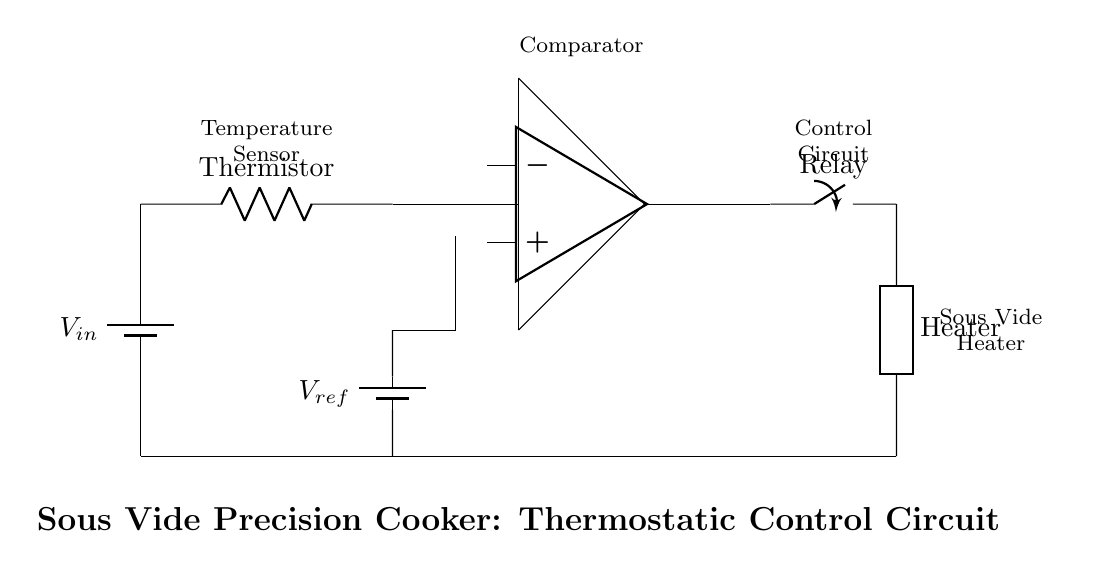What is the type of temperature sensor used? The circuit diagram indicates a thermistor is used as the temperature sensor, which is represented by the labeled resistor.
Answer: Thermistor What does the comparator do in this circuit? The comparator compares the voltage from the thermistor with the reference voltage to control the relay, allowing the heater to turn on or off based on the desired temperature.
Answer: Control relay What is the reference voltage labeled in the circuit? The circuit shows that the reference voltage is denoted as V_ref and is a battery supplying voltage at the lower part of the comparator.
Answer: V_ref What component directly controls the heating element? The relay serves as a switch that is controlled by the comparator’s output, allowing the current to flow to the heater when activated.
Answer: Relay How many major components are in this circuit? The circuit consists of four major components: thermistor, comparator, relay, and heater. Counting each distinct part gives a total of four.
Answer: Four What is the primary function of this control circuit? The control circuit maintains the water temperature at a desired level in the sous vide cooking process by activating or deactivating the heater through the relay based on temperature feedback.
Answer: Maintain temperature 